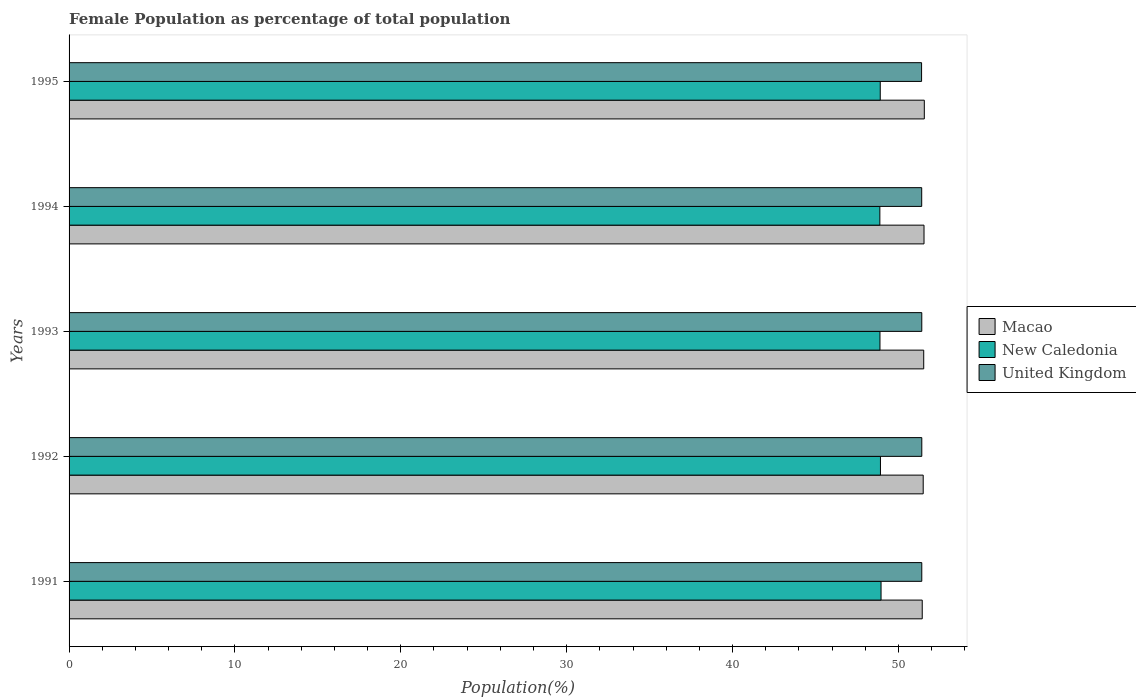How many different coloured bars are there?
Your answer should be very brief. 3. How many groups of bars are there?
Your answer should be compact. 5. Are the number of bars per tick equal to the number of legend labels?
Your answer should be compact. Yes. How many bars are there on the 5th tick from the top?
Your response must be concise. 3. What is the label of the 1st group of bars from the top?
Offer a very short reply. 1995. In how many cases, is the number of bars for a given year not equal to the number of legend labels?
Provide a short and direct response. 0. What is the female population in in Macao in 1994?
Give a very brief answer. 51.54. Across all years, what is the maximum female population in in New Caledonia?
Offer a terse response. 48.95. Across all years, what is the minimum female population in in Macao?
Your answer should be compact. 51.44. In which year was the female population in in Macao maximum?
Provide a succinct answer. 1995. What is the total female population in in New Caledonia in the graph?
Provide a succinct answer. 244.55. What is the difference between the female population in in New Caledonia in 1991 and that in 1994?
Offer a terse response. 0.07. What is the difference between the female population in in Macao in 1993 and the female population in in United Kingdom in 1991?
Provide a succinct answer. 0.12. What is the average female population in in New Caledonia per year?
Keep it short and to the point. 48.91. In the year 1995, what is the difference between the female population in in United Kingdom and female population in in New Caledonia?
Offer a terse response. 2.49. In how many years, is the female population in in United Kingdom greater than 16 %?
Provide a succinct answer. 5. What is the ratio of the female population in in New Caledonia in 1991 to that in 1995?
Provide a short and direct response. 1. Is the female population in in Macao in 1992 less than that in 1995?
Offer a terse response. Yes. What is the difference between the highest and the second highest female population in in New Caledonia?
Your response must be concise. 0.04. What is the difference between the highest and the lowest female population in in Macao?
Keep it short and to the point. 0.13. Is the sum of the female population in in United Kingdom in 1993 and 1995 greater than the maximum female population in in New Caledonia across all years?
Your answer should be compact. Yes. What does the 2nd bar from the top in 1994 represents?
Your answer should be very brief. New Caledonia. What does the 3rd bar from the bottom in 1993 represents?
Provide a short and direct response. United Kingdom. How many years are there in the graph?
Keep it short and to the point. 5. Does the graph contain any zero values?
Your response must be concise. No. Where does the legend appear in the graph?
Your response must be concise. Center right. How many legend labels are there?
Your response must be concise. 3. What is the title of the graph?
Give a very brief answer. Female Population as percentage of total population. What is the label or title of the X-axis?
Give a very brief answer. Population(%). What is the label or title of the Y-axis?
Offer a very short reply. Years. What is the Population(%) of Macao in 1991?
Ensure brevity in your answer.  51.44. What is the Population(%) of New Caledonia in 1991?
Provide a short and direct response. 48.95. What is the Population(%) of United Kingdom in 1991?
Offer a terse response. 51.41. What is the Population(%) of Macao in 1992?
Keep it short and to the point. 51.5. What is the Population(%) of New Caledonia in 1992?
Make the answer very short. 48.92. What is the Population(%) of United Kingdom in 1992?
Your answer should be compact. 51.41. What is the Population(%) in Macao in 1993?
Your answer should be very brief. 51.53. What is the Population(%) of New Caledonia in 1993?
Keep it short and to the point. 48.89. What is the Population(%) of United Kingdom in 1993?
Provide a short and direct response. 51.41. What is the Population(%) in Macao in 1994?
Provide a short and direct response. 51.54. What is the Population(%) in New Caledonia in 1994?
Make the answer very short. 48.88. What is the Population(%) of United Kingdom in 1994?
Keep it short and to the point. 51.41. What is the Population(%) of Macao in 1995?
Your answer should be very brief. 51.56. What is the Population(%) in New Caledonia in 1995?
Keep it short and to the point. 48.91. What is the Population(%) in United Kingdom in 1995?
Ensure brevity in your answer.  51.4. Across all years, what is the maximum Population(%) in Macao?
Ensure brevity in your answer.  51.56. Across all years, what is the maximum Population(%) in New Caledonia?
Offer a terse response. 48.95. Across all years, what is the maximum Population(%) of United Kingdom?
Keep it short and to the point. 51.41. Across all years, what is the minimum Population(%) of Macao?
Provide a short and direct response. 51.44. Across all years, what is the minimum Population(%) in New Caledonia?
Keep it short and to the point. 48.88. Across all years, what is the minimum Population(%) of United Kingdom?
Your answer should be compact. 51.4. What is the total Population(%) in Macao in the graph?
Keep it short and to the point. 257.56. What is the total Population(%) in New Caledonia in the graph?
Make the answer very short. 244.55. What is the total Population(%) in United Kingdom in the graph?
Offer a very short reply. 257.03. What is the difference between the Population(%) of Macao in 1991 and that in 1992?
Give a very brief answer. -0.06. What is the difference between the Population(%) of New Caledonia in 1991 and that in 1992?
Keep it short and to the point. 0.04. What is the difference between the Population(%) of United Kingdom in 1991 and that in 1992?
Provide a short and direct response. -0. What is the difference between the Population(%) of Macao in 1991 and that in 1993?
Your answer should be compact. -0.09. What is the difference between the Population(%) in New Caledonia in 1991 and that in 1993?
Your response must be concise. 0.07. What is the difference between the Population(%) of Macao in 1991 and that in 1994?
Keep it short and to the point. -0.11. What is the difference between the Population(%) in New Caledonia in 1991 and that in 1994?
Your answer should be compact. 0.07. What is the difference between the Population(%) of United Kingdom in 1991 and that in 1994?
Provide a short and direct response. 0. What is the difference between the Population(%) of Macao in 1991 and that in 1995?
Give a very brief answer. -0.13. What is the difference between the Population(%) in New Caledonia in 1991 and that in 1995?
Provide a succinct answer. 0.05. What is the difference between the Population(%) of United Kingdom in 1991 and that in 1995?
Offer a very short reply. 0.01. What is the difference between the Population(%) in Macao in 1992 and that in 1993?
Give a very brief answer. -0.03. What is the difference between the Population(%) of New Caledonia in 1992 and that in 1993?
Offer a very short reply. 0.03. What is the difference between the Population(%) of United Kingdom in 1992 and that in 1993?
Your answer should be compact. 0. What is the difference between the Population(%) of Macao in 1992 and that in 1994?
Ensure brevity in your answer.  -0.05. What is the difference between the Population(%) of New Caledonia in 1992 and that in 1994?
Your answer should be very brief. 0.04. What is the difference between the Population(%) in United Kingdom in 1992 and that in 1994?
Keep it short and to the point. 0.01. What is the difference between the Population(%) of Macao in 1992 and that in 1995?
Ensure brevity in your answer.  -0.07. What is the difference between the Population(%) of New Caledonia in 1992 and that in 1995?
Offer a terse response. 0.01. What is the difference between the Population(%) in United Kingdom in 1992 and that in 1995?
Make the answer very short. 0.01. What is the difference between the Population(%) of Macao in 1993 and that in 1994?
Offer a terse response. -0.02. What is the difference between the Population(%) in New Caledonia in 1993 and that in 1994?
Offer a very short reply. 0.01. What is the difference between the Population(%) in United Kingdom in 1993 and that in 1994?
Provide a succinct answer. 0. What is the difference between the Population(%) of Macao in 1993 and that in 1995?
Make the answer very short. -0.04. What is the difference between the Population(%) of New Caledonia in 1993 and that in 1995?
Make the answer very short. -0.02. What is the difference between the Population(%) in United Kingdom in 1993 and that in 1995?
Provide a succinct answer. 0.01. What is the difference between the Population(%) in Macao in 1994 and that in 1995?
Give a very brief answer. -0.02. What is the difference between the Population(%) of New Caledonia in 1994 and that in 1995?
Give a very brief answer. -0.02. What is the difference between the Population(%) of United Kingdom in 1994 and that in 1995?
Your answer should be very brief. 0.01. What is the difference between the Population(%) of Macao in 1991 and the Population(%) of New Caledonia in 1992?
Offer a very short reply. 2.52. What is the difference between the Population(%) of Macao in 1991 and the Population(%) of United Kingdom in 1992?
Your answer should be very brief. 0.03. What is the difference between the Population(%) in New Caledonia in 1991 and the Population(%) in United Kingdom in 1992?
Ensure brevity in your answer.  -2.46. What is the difference between the Population(%) of Macao in 1991 and the Population(%) of New Caledonia in 1993?
Give a very brief answer. 2.55. What is the difference between the Population(%) of Macao in 1991 and the Population(%) of United Kingdom in 1993?
Your answer should be compact. 0.03. What is the difference between the Population(%) of New Caledonia in 1991 and the Population(%) of United Kingdom in 1993?
Your response must be concise. -2.46. What is the difference between the Population(%) of Macao in 1991 and the Population(%) of New Caledonia in 1994?
Offer a very short reply. 2.55. What is the difference between the Population(%) in Macao in 1991 and the Population(%) in United Kingdom in 1994?
Your answer should be compact. 0.03. What is the difference between the Population(%) in New Caledonia in 1991 and the Population(%) in United Kingdom in 1994?
Keep it short and to the point. -2.45. What is the difference between the Population(%) of Macao in 1991 and the Population(%) of New Caledonia in 1995?
Your answer should be very brief. 2.53. What is the difference between the Population(%) in Macao in 1991 and the Population(%) in United Kingdom in 1995?
Your answer should be very brief. 0.04. What is the difference between the Population(%) of New Caledonia in 1991 and the Population(%) of United Kingdom in 1995?
Your answer should be compact. -2.44. What is the difference between the Population(%) of Macao in 1992 and the Population(%) of New Caledonia in 1993?
Ensure brevity in your answer.  2.61. What is the difference between the Population(%) of Macao in 1992 and the Population(%) of United Kingdom in 1993?
Provide a short and direct response. 0.09. What is the difference between the Population(%) of New Caledonia in 1992 and the Population(%) of United Kingdom in 1993?
Your answer should be compact. -2.49. What is the difference between the Population(%) of Macao in 1992 and the Population(%) of New Caledonia in 1994?
Offer a terse response. 2.61. What is the difference between the Population(%) in Macao in 1992 and the Population(%) in United Kingdom in 1994?
Make the answer very short. 0.09. What is the difference between the Population(%) in New Caledonia in 1992 and the Population(%) in United Kingdom in 1994?
Ensure brevity in your answer.  -2.49. What is the difference between the Population(%) of Macao in 1992 and the Population(%) of New Caledonia in 1995?
Ensure brevity in your answer.  2.59. What is the difference between the Population(%) of Macao in 1992 and the Population(%) of United Kingdom in 1995?
Your response must be concise. 0.1. What is the difference between the Population(%) of New Caledonia in 1992 and the Population(%) of United Kingdom in 1995?
Provide a succinct answer. -2.48. What is the difference between the Population(%) of Macao in 1993 and the Population(%) of New Caledonia in 1994?
Provide a short and direct response. 2.64. What is the difference between the Population(%) of Macao in 1993 and the Population(%) of United Kingdom in 1994?
Make the answer very short. 0.12. What is the difference between the Population(%) in New Caledonia in 1993 and the Population(%) in United Kingdom in 1994?
Your answer should be compact. -2.52. What is the difference between the Population(%) in Macao in 1993 and the Population(%) in New Caledonia in 1995?
Ensure brevity in your answer.  2.62. What is the difference between the Population(%) in Macao in 1993 and the Population(%) in United Kingdom in 1995?
Your answer should be very brief. 0.13. What is the difference between the Population(%) in New Caledonia in 1993 and the Population(%) in United Kingdom in 1995?
Provide a short and direct response. -2.51. What is the difference between the Population(%) in Macao in 1994 and the Population(%) in New Caledonia in 1995?
Give a very brief answer. 2.64. What is the difference between the Population(%) in Macao in 1994 and the Population(%) in United Kingdom in 1995?
Your answer should be very brief. 0.15. What is the difference between the Population(%) of New Caledonia in 1994 and the Population(%) of United Kingdom in 1995?
Your answer should be very brief. -2.52. What is the average Population(%) of Macao per year?
Ensure brevity in your answer.  51.51. What is the average Population(%) in New Caledonia per year?
Provide a succinct answer. 48.91. What is the average Population(%) of United Kingdom per year?
Keep it short and to the point. 51.41. In the year 1991, what is the difference between the Population(%) in Macao and Population(%) in New Caledonia?
Provide a succinct answer. 2.48. In the year 1991, what is the difference between the Population(%) in Macao and Population(%) in United Kingdom?
Offer a terse response. 0.03. In the year 1991, what is the difference between the Population(%) in New Caledonia and Population(%) in United Kingdom?
Provide a succinct answer. -2.46. In the year 1992, what is the difference between the Population(%) of Macao and Population(%) of New Caledonia?
Provide a short and direct response. 2.58. In the year 1992, what is the difference between the Population(%) in Macao and Population(%) in United Kingdom?
Your response must be concise. 0.09. In the year 1992, what is the difference between the Population(%) of New Caledonia and Population(%) of United Kingdom?
Make the answer very short. -2.49. In the year 1993, what is the difference between the Population(%) in Macao and Population(%) in New Caledonia?
Your answer should be compact. 2.64. In the year 1993, what is the difference between the Population(%) of Macao and Population(%) of United Kingdom?
Give a very brief answer. 0.12. In the year 1993, what is the difference between the Population(%) in New Caledonia and Population(%) in United Kingdom?
Your response must be concise. -2.52. In the year 1994, what is the difference between the Population(%) of Macao and Population(%) of New Caledonia?
Ensure brevity in your answer.  2.66. In the year 1994, what is the difference between the Population(%) of Macao and Population(%) of United Kingdom?
Offer a terse response. 0.14. In the year 1994, what is the difference between the Population(%) of New Caledonia and Population(%) of United Kingdom?
Your answer should be very brief. -2.52. In the year 1995, what is the difference between the Population(%) in Macao and Population(%) in New Caledonia?
Give a very brief answer. 2.66. In the year 1995, what is the difference between the Population(%) in Macao and Population(%) in United Kingdom?
Your answer should be compact. 0.17. In the year 1995, what is the difference between the Population(%) of New Caledonia and Population(%) of United Kingdom?
Provide a succinct answer. -2.49. What is the ratio of the Population(%) in Macao in 1991 to that in 1992?
Provide a succinct answer. 1. What is the ratio of the Population(%) in United Kingdom in 1991 to that in 1993?
Your answer should be compact. 1. What is the ratio of the Population(%) of New Caledonia in 1991 to that in 1994?
Keep it short and to the point. 1. What is the ratio of the Population(%) in United Kingdom in 1991 to that in 1994?
Ensure brevity in your answer.  1. What is the ratio of the Population(%) of Macao in 1991 to that in 1995?
Make the answer very short. 1. What is the ratio of the Population(%) in Macao in 1992 to that in 1993?
Your response must be concise. 1. What is the ratio of the Population(%) in New Caledonia in 1992 to that in 1993?
Make the answer very short. 1. What is the ratio of the Population(%) of United Kingdom in 1992 to that in 1993?
Provide a succinct answer. 1. What is the ratio of the Population(%) of Macao in 1992 to that in 1994?
Provide a short and direct response. 1. What is the ratio of the Population(%) in United Kingdom in 1992 to that in 1995?
Keep it short and to the point. 1. What is the ratio of the Population(%) in Macao in 1993 to that in 1994?
Your response must be concise. 1. What is the ratio of the Population(%) in New Caledonia in 1993 to that in 1994?
Give a very brief answer. 1. What is the ratio of the Population(%) of United Kingdom in 1993 to that in 1994?
Give a very brief answer. 1. What is the ratio of the Population(%) of New Caledonia in 1994 to that in 1995?
Give a very brief answer. 1. What is the ratio of the Population(%) in United Kingdom in 1994 to that in 1995?
Provide a succinct answer. 1. What is the difference between the highest and the second highest Population(%) of Macao?
Keep it short and to the point. 0.02. What is the difference between the highest and the second highest Population(%) of New Caledonia?
Offer a very short reply. 0.04. What is the difference between the highest and the lowest Population(%) of Macao?
Provide a short and direct response. 0.13. What is the difference between the highest and the lowest Population(%) in New Caledonia?
Your response must be concise. 0.07. What is the difference between the highest and the lowest Population(%) of United Kingdom?
Make the answer very short. 0.01. 